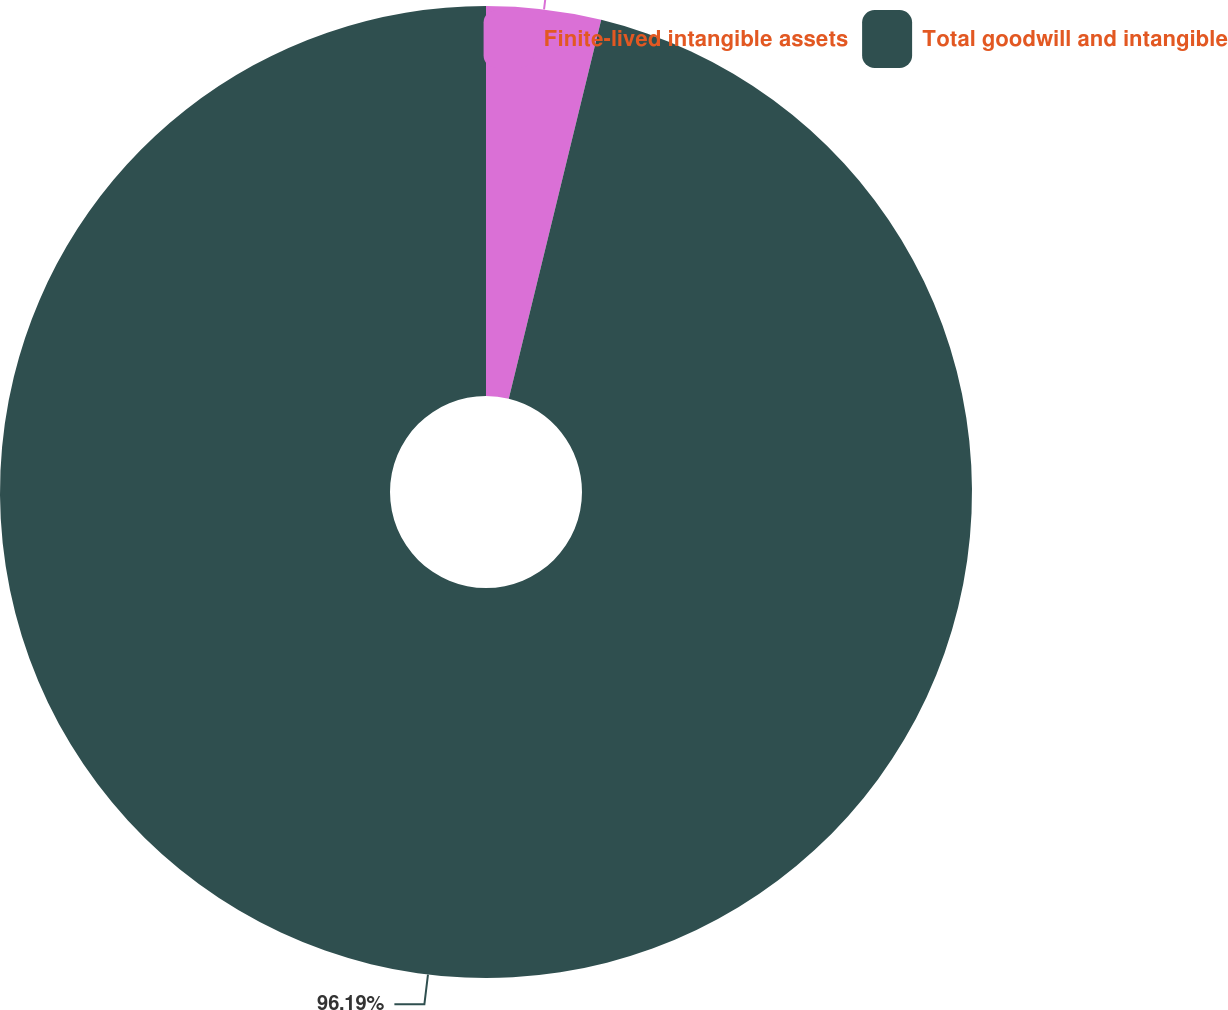<chart> <loc_0><loc_0><loc_500><loc_500><pie_chart><fcel>Finite-lived intangible assets<fcel>Total goodwill and intangible<nl><fcel>3.81%<fcel>96.19%<nl></chart> 